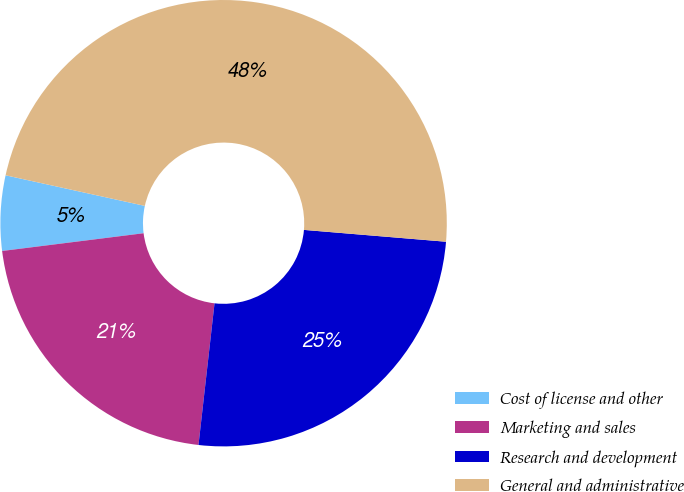Convert chart. <chart><loc_0><loc_0><loc_500><loc_500><pie_chart><fcel>Cost of license and other<fcel>Marketing and sales<fcel>Research and development<fcel>General and administrative<nl><fcel>5.43%<fcel>21.22%<fcel>25.47%<fcel>47.88%<nl></chart> 